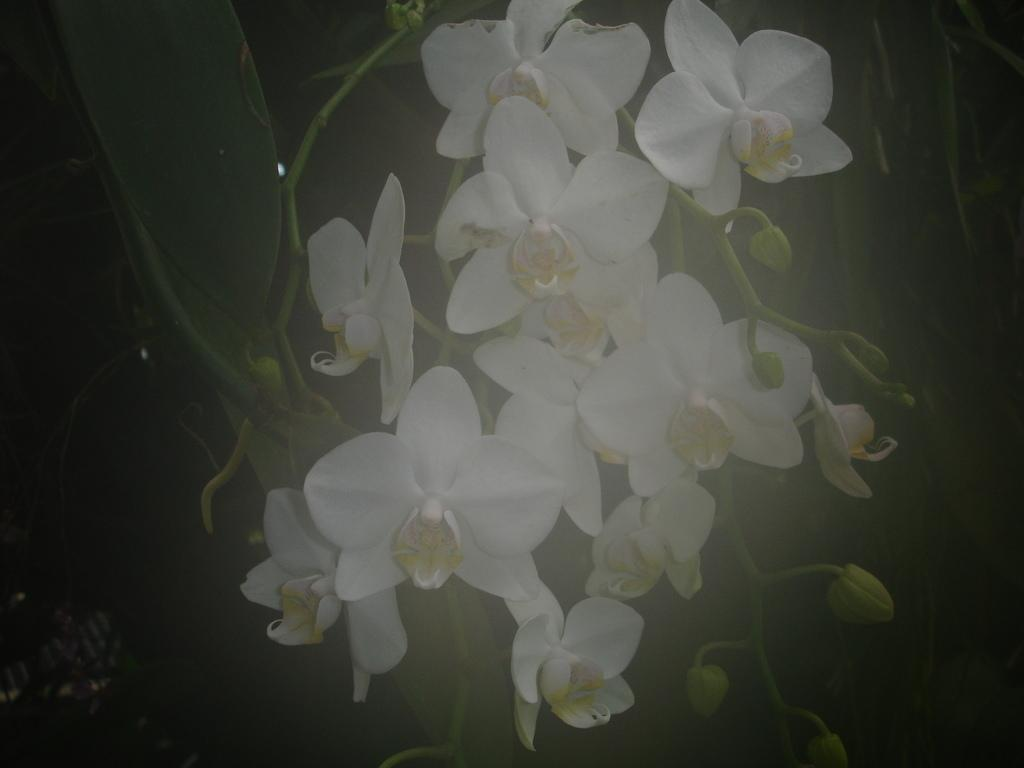What type of living organisms can be seen in the image? Plants can be seen in the image. What specific feature of the plants is visible? The plants have flowers. What color are the flowers? The flowers are white in color. What is the color of the background in the image? The background of the image is black. Can you tell me how many writers are present in the image? There are no writers present in the image; it features plants with white flowers against a black background. What type of zephyr can be seen interacting with the plants in the image? There is no zephyr present in the image; it only features plants with white flowers against a black background. 